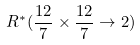Convert formula to latex. <formula><loc_0><loc_0><loc_500><loc_500>R ^ { * } ( \frac { 1 2 } { 7 } \times \frac { 1 2 } { 7 } \to 2 )</formula> 